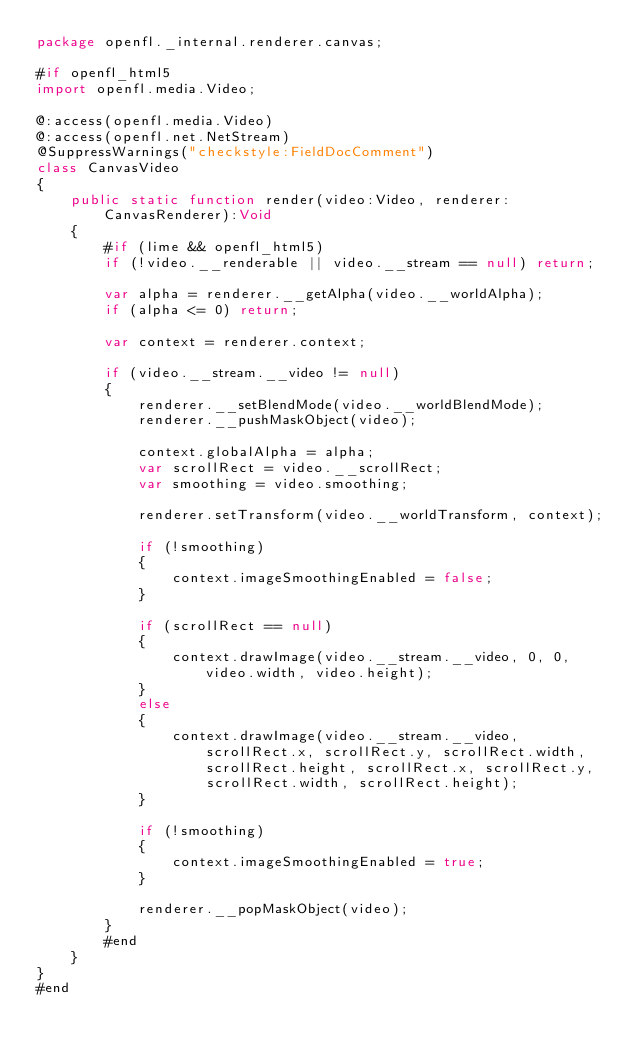Convert code to text. <code><loc_0><loc_0><loc_500><loc_500><_Haxe_>package openfl._internal.renderer.canvas;

#if openfl_html5
import openfl.media.Video;

@:access(openfl.media.Video)
@:access(openfl.net.NetStream)
@SuppressWarnings("checkstyle:FieldDocComment")
class CanvasVideo
{
	public static function render(video:Video, renderer:CanvasRenderer):Void
	{
		#if (lime && openfl_html5)
		if (!video.__renderable || video.__stream == null) return;

		var alpha = renderer.__getAlpha(video.__worldAlpha);
		if (alpha <= 0) return;

		var context = renderer.context;

		if (video.__stream.__video != null)
		{
			renderer.__setBlendMode(video.__worldBlendMode);
			renderer.__pushMaskObject(video);

			context.globalAlpha = alpha;
			var scrollRect = video.__scrollRect;
			var smoothing = video.smoothing;

			renderer.setTransform(video.__worldTransform, context);

			if (!smoothing)
			{
				context.imageSmoothingEnabled = false;
			}

			if (scrollRect == null)
			{
				context.drawImage(video.__stream.__video, 0, 0, video.width, video.height);
			}
			else
			{
				context.drawImage(video.__stream.__video, scrollRect.x, scrollRect.y, scrollRect.width, scrollRect.height, scrollRect.x, scrollRect.y,
					scrollRect.width, scrollRect.height);
			}

			if (!smoothing)
			{
				context.imageSmoothingEnabled = true;
			}

			renderer.__popMaskObject(video);
		}
		#end
	}
}
#end
</code> 